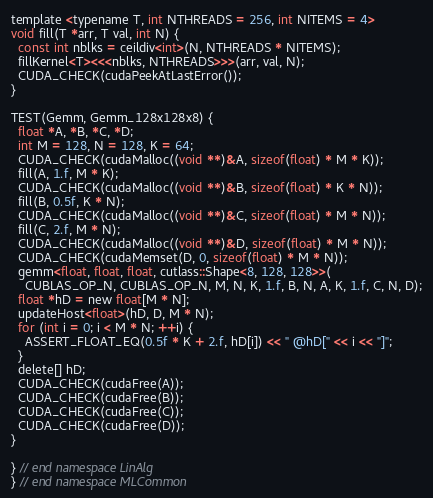Convert code to text. <code><loc_0><loc_0><loc_500><loc_500><_Cuda_>template <typename T, int NTHREADS = 256, int NITEMS = 4>
void fill(T *arr, T val, int N) {
  const int nblks = ceildiv<int>(N, NTHREADS * NITEMS);
  fillKernel<T><<<nblks, NTHREADS>>>(arr, val, N);
  CUDA_CHECK(cudaPeekAtLastError());
}

TEST(Gemm, Gemm_128x128x8) {
  float *A, *B, *C, *D;
  int M = 128, N = 128, K = 64;
  CUDA_CHECK(cudaMalloc((void **)&A, sizeof(float) * M * K));
  fill(A, 1.f, M * K);
  CUDA_CHECK(cudaMalloc((void **)&B, sizeof(float) * K * N));
  fill(B, 0.5f, K * N);
  CUDA_CHECK(cudaMalloc((void **)&C, sizeof(float) * M * N));
  fill(C, 2.f, M * N);
  CUDA_CHECK(cudaMalloc((void **)&D, sizeof(float) * M * N));
  CUDA_CHECK(cudaMemset(D, 0, sizeof(float) * M * N));
  gemm<float, float, float, cutlass::Shape<8, 128, 128>>(
    CUBLAS_OP_N, CUBLAS_OP_N, M, N, K, 1.f, B, N, A, K, 1.f, C, N, D);
  float *hD = new float[M * N];
  updateHost<float>(hD, D, M * N);
  for (int i = 0; i < M * N; ++i) {
    ASSERT_FLOAT_EQ(0.5f * K + 2.f, hD[i]) << " @hD[" << i << "]";
  }
  delete[] hD;
  CUDA_CHECK(cudaFree(A));
  CUDA_CHECK(cudaFree(B));
  CUDA_CHECK(cudaFree(C));
  CUDA_CHECK(cudaFree(D));
}

} // end namespace LinAlg
} // end namespace MLCommon
</code> 